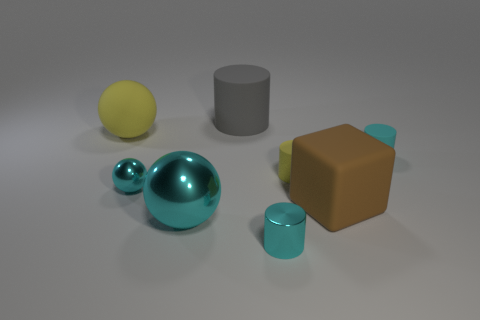Add 1 big objects. How many objects exist? 9 Subtract all blocks. How many objects are left? 7 Subtract 0 green blocks. How many objects are left? 8 Subtract all small yellow matte cylinders. Subtract all gray objects. How many objects are left? 6 Add 8 gray objects. How many gray objects are left? 9 Add 6 cyan metallic cylinders. How many cyan metallic cylinders exist? 7 